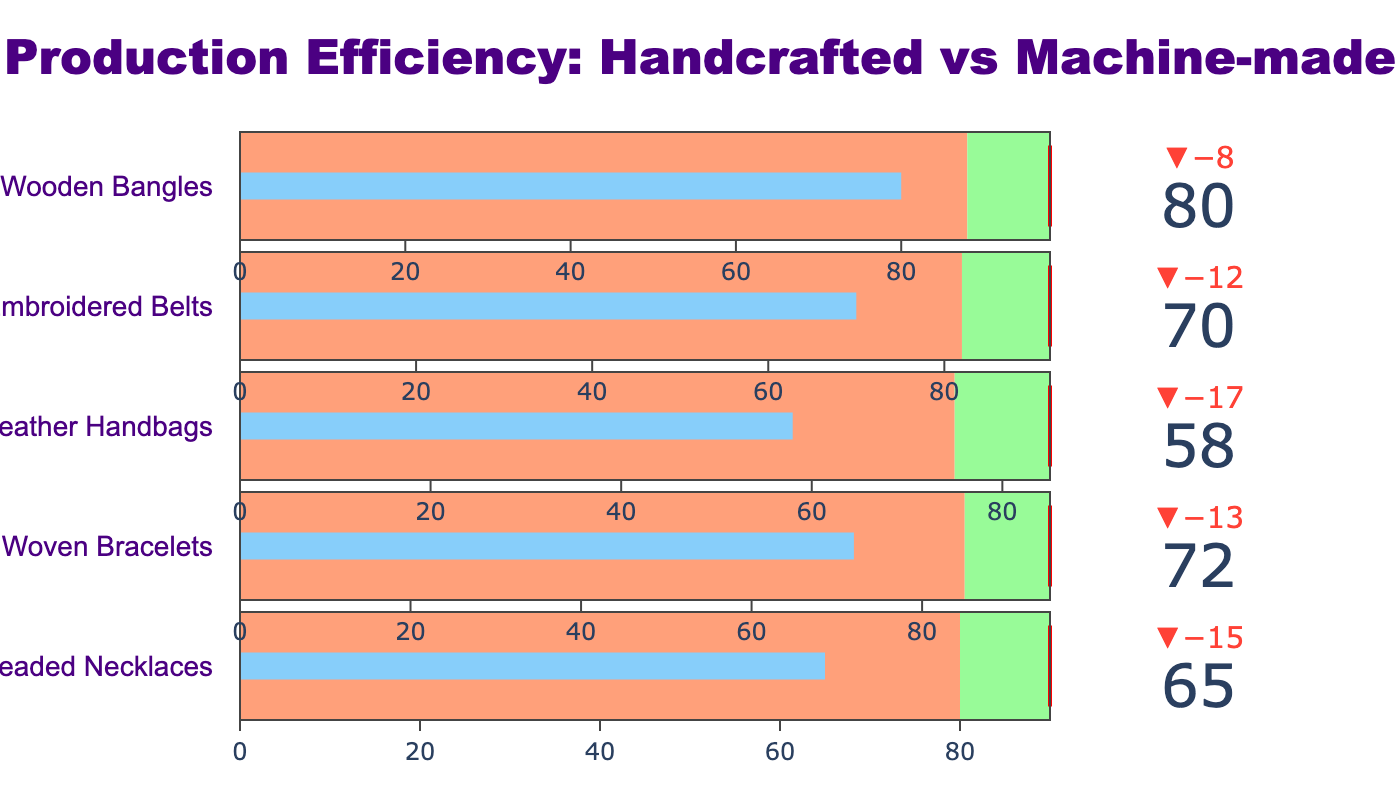What's the title of the chart? The title of the chart is usually displayed prominently at the top of the figure. In this case, it reads "Production Efficiency: Handcrafted vs Machine-made".
Answer: Production Efficiency: Handcrafted vs Machine-made What's the actual production efficiency of Beaded Necklaces? The actual production efficiency can be found by looking at the bullet indicator specifically for Beaded Necklaces, where the number in the gauge points to 65.
Answer: 65 What are the comparative and target efficiency levels for Leather Handbags? For Leather Handbags, the comparative efficiency level is 75 and the target efficiency level is 85, as indicated on the respective bullet graph for this category.
Answer: 75 and 85 What's the color of the bar representing actual values in the chart? The color of the bar representing the actual values in each bullet gauge is uniform throughout the chart, displayed as blue.
Answer: blue Which category has the highest actual production efficiency? By examining the actual values in each bullet graph, it's clear that Wooden Bangles has the highest actual production efficiency, with a value of 80.
Answer: Wooden Bangles What's the difference between the target and actual production efficiency for Embroidered Belts? Looking at the Embroidered Belts section, the target is 92, and the actual is 70. The difference is calculated as 92 - 70 = 22.
Answer: 22 Which category is closest to meeting its target efficiency? To determine which category is closest to meeting its target, compare the actual values and targets for each category. Wooden Bangles, with an actual of 80 and a target of 98, is the closest because the difference (98 - 80) is 18, which is the smallest among all categories.
Answer: Wooden Bangles How many categories have actual efficiency below their comparative efficiency? By comparing the actual and comparative values for each category, we see that all categories (Beaded Necklaces, Woven Bracelets, Leather Handbags, Embroidered Belts, Wooden Bangles) have their actual efficiency below their comparative efficiency.
Answer: 5 What's the cumulative actual production efficiency of all categories combined? Sum the actual values for each category: 65 (Beaded Necklaces) + 72 (Woven Bracelets) + 58 (Leather Handbags) + 70 (Embroidered Belts) + 80 (Wooden Bangles) = 345.
Answer: 345 